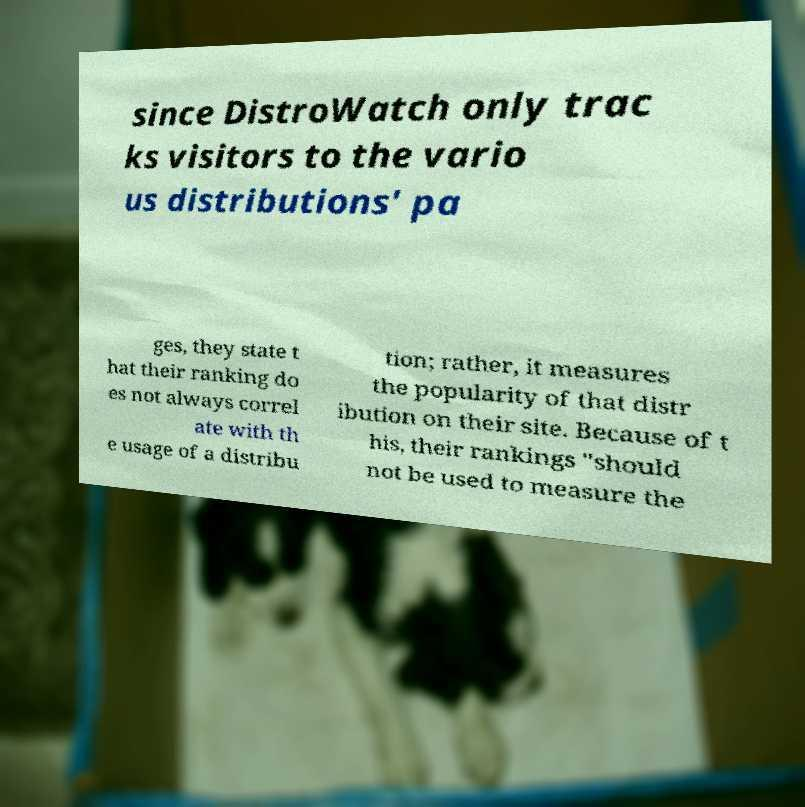Can you accurately transcribe the text from the provided image for me? since DistroWatch only trac ks visitors to the vario us distributions' pa ges, they state t hat their ranking do es not always correl ate with th e usage of a distribu tion; rather, it measures the popularity of that distr ibution on their site. Because of t his, their rankings "should not be used to measure the 